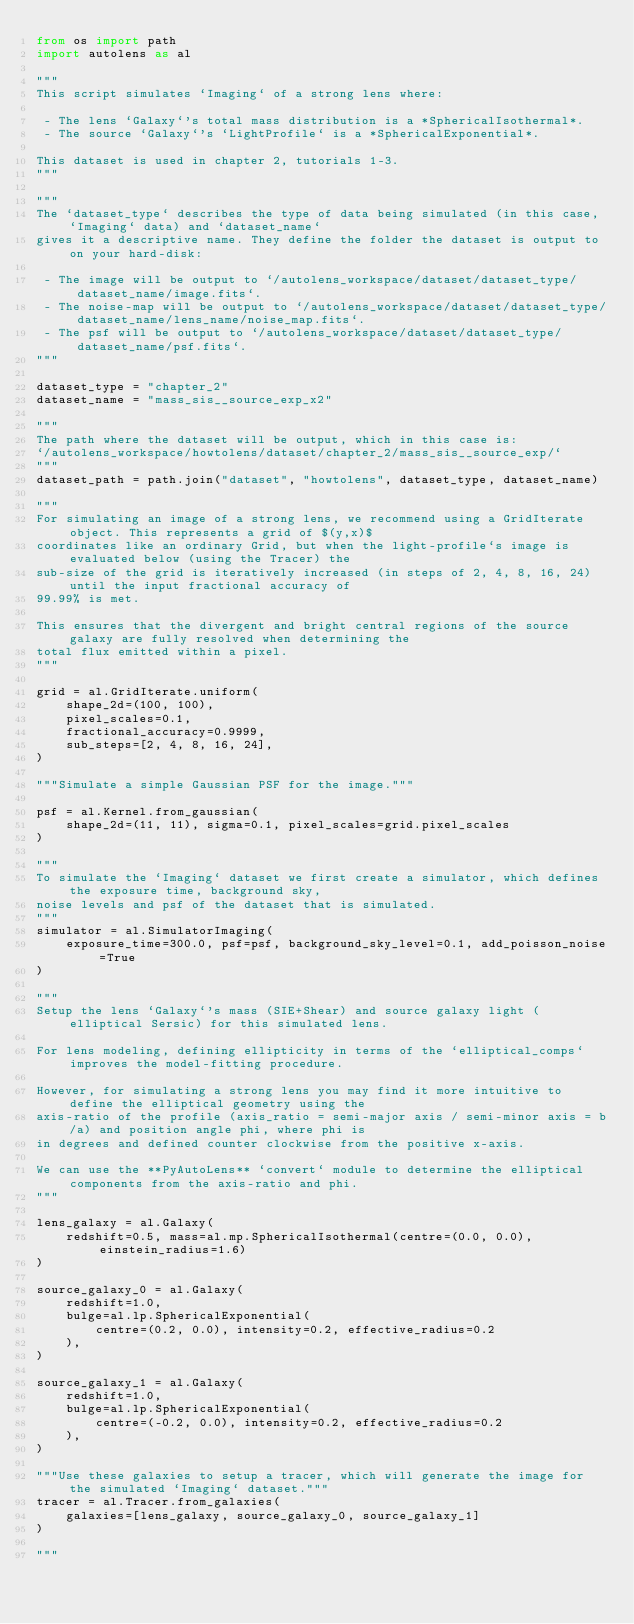<code> <loc_0><loc_0><loc_500><loc_500><_Python_>from os import path
import autolens as al

"""
This script simulates `Imaging` of a strong lens where:

 - The lens `Galaxy`'s total mass distribution is a *SphericalIsothermal*.
 - The source `Galaxy`'s `LightProfile` is a *SphericalExponential*.
    
This dataset is used in chapter 2, tutorials 1-3.
"""

"""
The `dataset_type` describes the type of data being simulated (in this case, `Imaging` data) and `dataset_name` 
gives it a descriptive name. They define the folder the dataset is output to on your hard-disk:

 - The image will be output to `/autolens_workspace/dataset/dataset_type/dataset_name/image.fits`.
 - The noise-map will be output to `/autolens_workspace/dataset/dataset_type/dataset_name/lens_name/noise_map.fits`.
 - The psf will be output to `/autolens_workspace/dataset/dataset_type/dataset_name/psf.fits`.
"""

dataset_type = "chapter_2"
dataset_name = "mass_sis__source_exp_x2"

"""
The path where the dataset will be output, which in this case is:
`/autolens_workspace/howtolens/dataset/chapter_2/mass_sis__source_exp/`
"""
dataset_path = path.join("dataset", "howtolens", dataset_type, dataset_name)

"""
For simulating an image of a strong lens, we recommend using a GridIterate object. This represents a grid of $(y,x)$ 
coordinates like an ordinary Grid, but when the light-profile`s image is evaluated below (using the Tracer) the 
sub-size of the grid is iteratively increased (in steps of 2, 4, 8, 16, 24) until the input fractional accuracy of 
99.99% is met.

This ensures that the divergent and bright central regions of the source galaxy are fully resolved when determining the
total flux emitted within a pixel.
"""

grid = al.GridIterate.uniform(
    shape_2d=(100, 100),
    pixel_scales=0.1,
    fractional_accuracy=0.9999,
    sub_steps=[2, 4, 8, 16, 24],
)

"""Simulate a simple Gaussian PSF for the image."""

psf = al.Kernel.from_gaussian(
    shape_2d=(11, 11), sigma=0.1, pixel_scales=grid.pixel_scales
)

"""
To simulate the `Imaging` dataset we first create a simulator, which defines the exposure time, background sky,
noise levels and psf of the dataset that is simulated.
"""
simulator = al.SimulatorImaging(
    exposure_time=300.0, psf=psf, background_sky_level=0.1, add_poisson_noise=True
)

"""
Setup the lens `Galaxy`'s mass (SIE+Shear) and source galaxy light (elliptical Sersic) for this simulated lens.

For lens modeling, defining ellipticity in terms of the `elliptical_comps` improves the model-fitting procedure.

However, for simulating a strong lens you may find it more intuitive to define the elliptical geometry using the 
axis-ratio of the profile (axis_ratio = semi-major axis / semi-minor axis = b/a) and position angle phi, where phi is
in degrees and defined counter clockwise from the positive x-axis.

We can use the **PyAutoLens** `convert` module to determine the elliptical components from the axis-ratio and phi.
"""

lens_galaxy = al.Galaxy(
    redshift=0.5, mass=al.mp.SphericalIsothermal(centre=(0.0, 0.0), einstein_radius=1.6)
)

source_galaxy_0 = al.Galaxy(
    redshift=1.0,
    bulge=al.lp.SphericalExponential(
        centre=(0.2, 0.0), intensity=0.2, effective_radius=0.2
    ),
)

source_galaxy_1 = al.Galaxy(
    redshift=1.0,
    bulge=al.lp.SphericalExponential(
        centre=(-0.2, 0.0), intensity=0.2, effective_radius=0.2
    ),
)

"""Use these galaxies to setup a tracer, which will generate the image for the simulated `Imaging` dataset."""
tracer = al.Tracer.from_galaxies(
    galaxies=[lens_galaxy, source_galaxy_0, source_galaxy_1]
)

"""</code> 